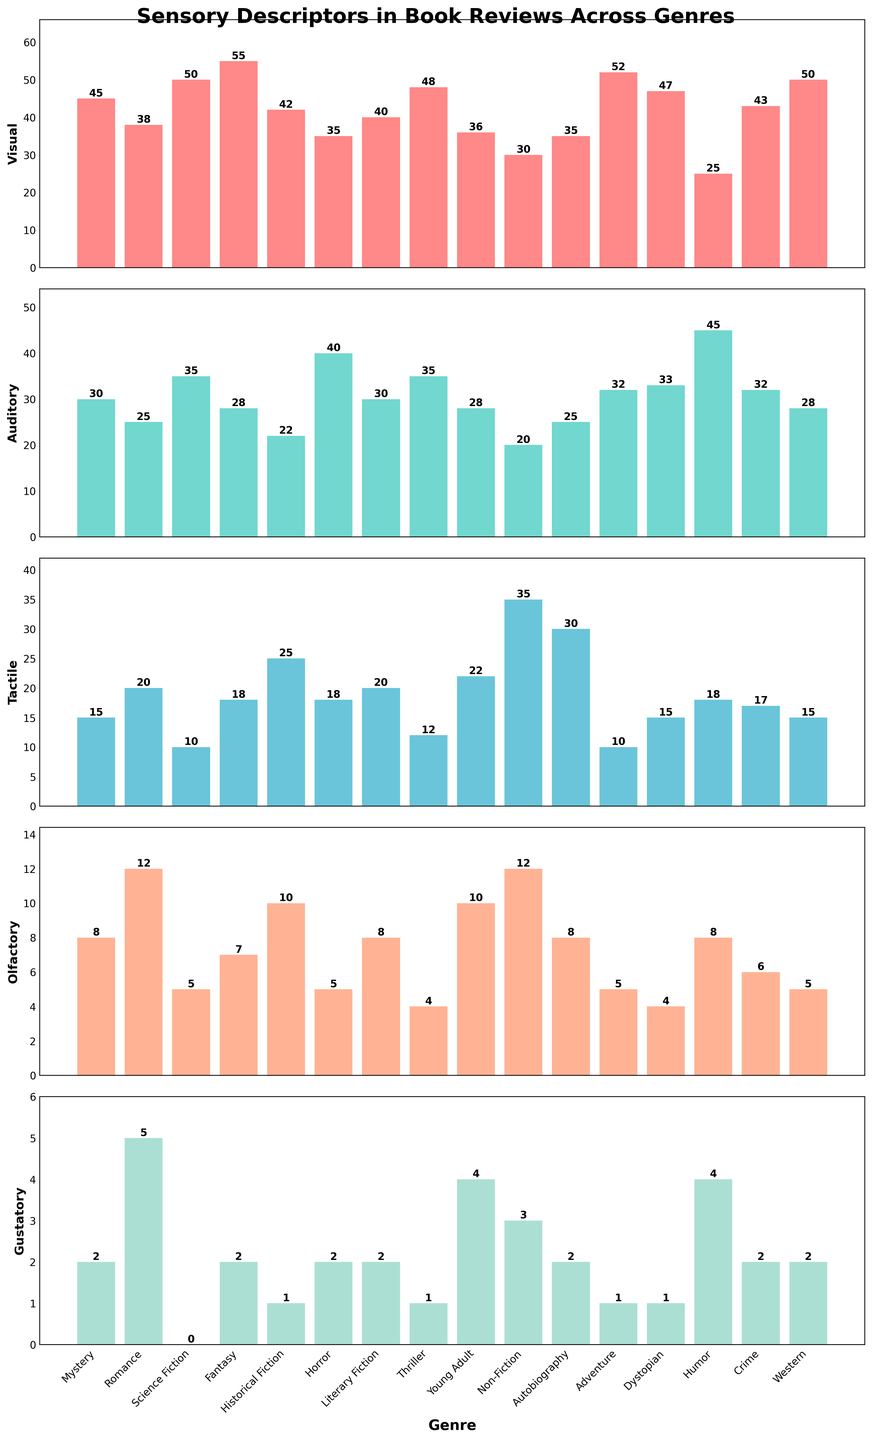what genre has the highest number of visual descriptors? The bar representing Fantasy has the tallest height in the "Visual" subplot, indicating it has the highest number of visual descriptors.
Answer: Fantasy Which genre has the lowest number of gustatory descriptors? By comparing the heights of the bars in the "Gustatory" subplot, Science Fiction has the shortest bar, indicating it has the lowest number of gustatory descriptors.
Answer: Science Fiction In which genre are auditory descriptors more frequently used than tactile ones? In genres like Horror, Thriller, and Humor, the height of the bars for auditory descriptors is taller than that for tactile descriptors.
Answer: Horror, Thriller, Humor What genres have exactly the same number of olfactory descriptors? The olfactory descriptors subplot shows that Mystery, Western, and Crime have bars of equal height.
Answer: Mystery, Western, Crime What is the mean number of tactile descriptors across all genres? Sum the tactile descriptor counts (15+20+10+18+25+18+20+12+22+35+30+10+15+18+17+15 = 300) and divide by the number of genres (16), 300 / 16 = 18.75.
Answer: 18.75 Which genre has the highest total sum of visual and auditory descriptors? Sum the visual and auditory counts for each genre and compare them. Fantasy has a sum of 83 (55+28), which is higher than any other genre.
Answer: Fantasy Which genre uses more tactile descriptors than visual descriptors? Compare the heights of tactile and visual bars; "Non-Fiction" and "Autobiography" show taller bars for tactile than visual descriptors.
Answer: Non-Fiction, Autobiography What's the difference in the number of visual descriptors between "Adventure" and "Romance"? The visual bar for Adventure is 52, and for Romance, it is 38. The difference is 52 - 38 = 14.
Answer: 14 Which sensory descriptor is the least used in reviews for "Literary Fiction"? In the subplot for Literary Fiction, the shortest bar is the Gustatory descriptor, indicating it is the least used.
Answer: Gustatory Out of "Mystery" and "Dystopian", which genre uses more olfactory descriptors? By comparing the bar heights for olfactory descriptors, Mystery has a taller bar at 8 compared to Dystopian's 4.
Answer: Mystery 